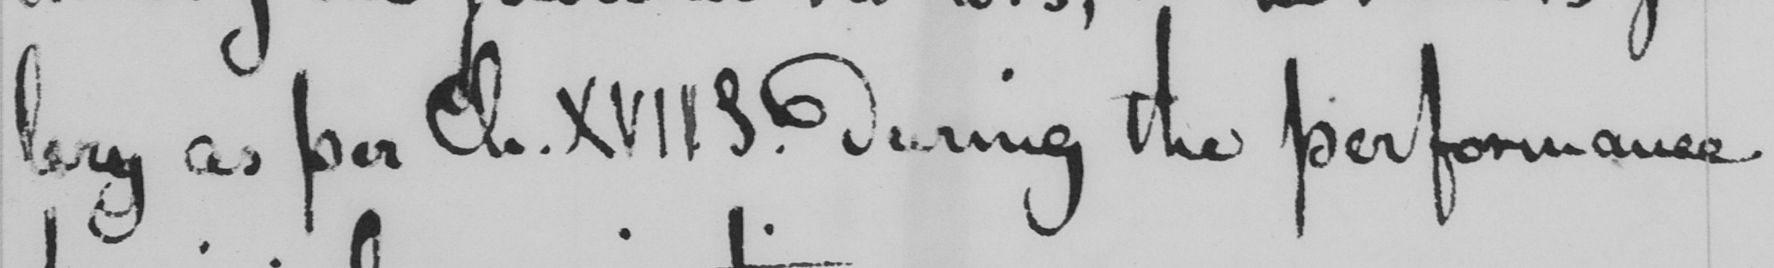Transcribe the text shown in this historical manuscript line. lery as per Ch . XVII S . during the performance 